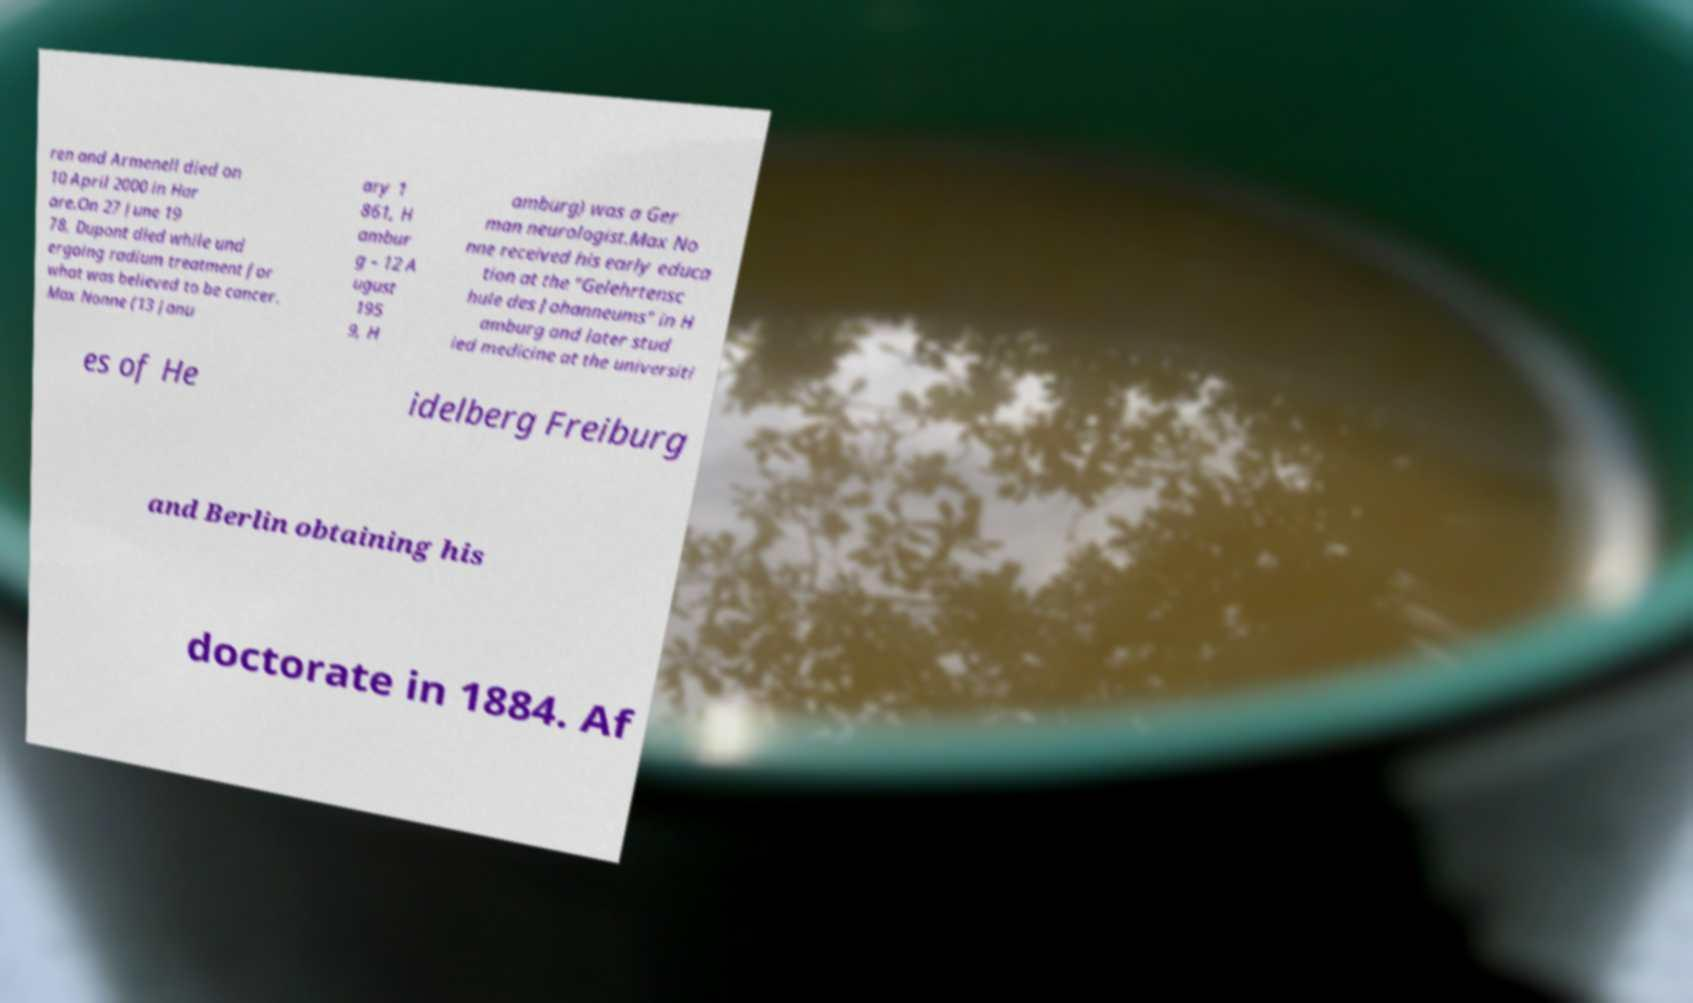Please read and relay the text visible in this image. What does it say? ren and Armenell died on 10 April 2000 in Har are.On 27 June 19 78, Dupont died while und ergoing radium treatment for what was believed to be cancer. Max Nonne (13 Janu ary 1 861, H ambur g – 12 A ugust 195 9, H amburg) was a Ger man neurologist.Max No nne received his early educa tion at the "Gelehrtensc hule des Johanneums" in H amburg and later stud ied medicine at the universiti es of He idelberg Freiburg and Berlin obtaining his doctorate in 1884. Af 